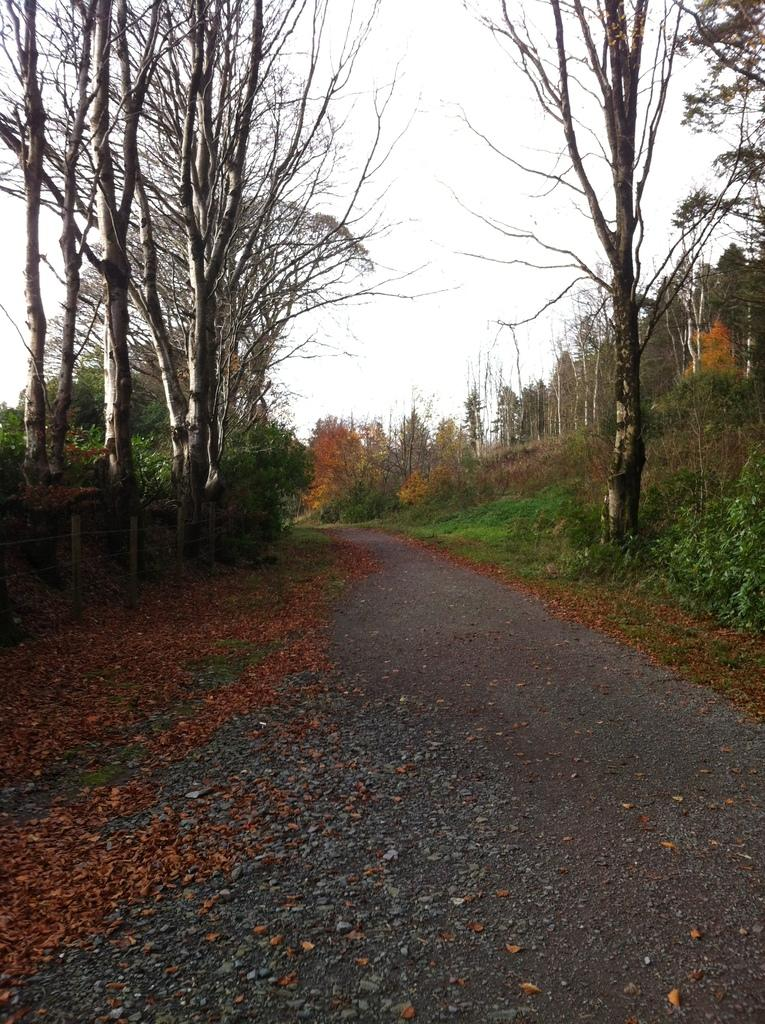What is the main feature of the image? There is a road in the image. What can be seen beside the road? There are trees beside the road. What type of vegetation is present in the image? There are plants and grass in the image. What else can be found in the image? There are leaves in the image. What is visible at the top of the image? The sky is visible at the top of the image. What type of grain is being harvested by the judge in the image? There is no grain or judge present in the image. 